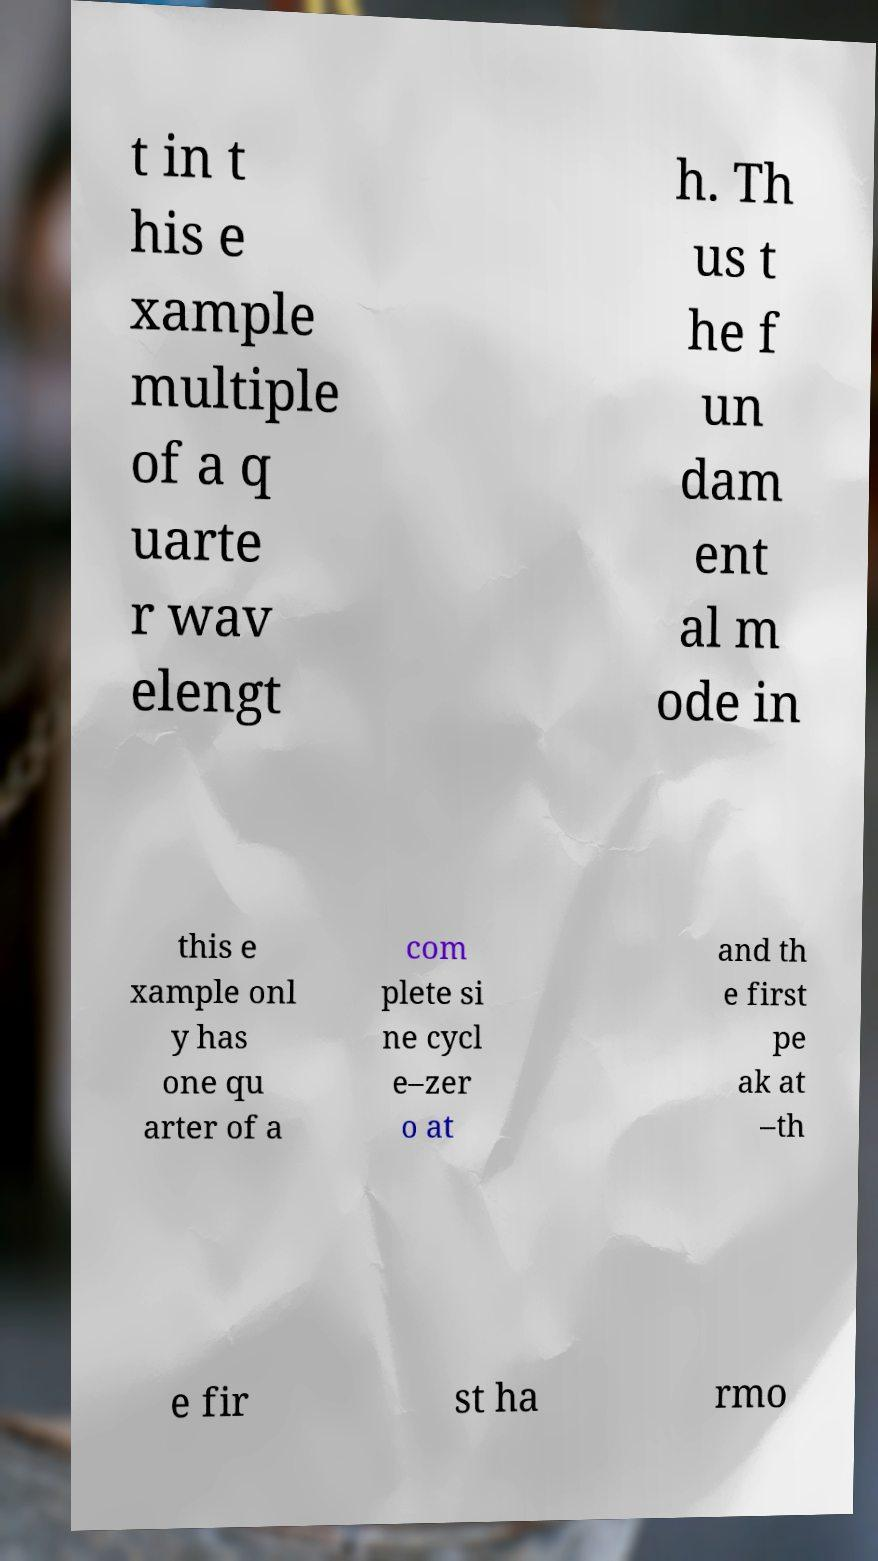Could you assist in decoding the text presented in this image and type it out clearly? t in t his e xample multiple of a q uarte r wav elengt h. Th us t he f un dam ent al m ode in this e xample onl y has one qu arter of a com plete si ne cycl e–zer o at and th e first pe ak at –th e fir st ha rmo 